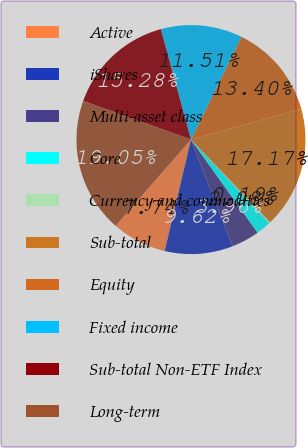Convert chart to OTSL. <chart><loc_0><loc_0><loc_500><loc_500><pie_chart><fcel>Active<fcel>iShares<fcel>Multi-asset class<fcel>Core<fcel>Currency and commodities<fcel>Sub-total<fcel>Equity<fcel>Fixed income<fcel>Sub-total Non-ETF Index<fcel>Long-term<nl><fcel>7.74%<fcel>9.62%<fcel>3.96%<fcel>2.08%<fcel>0.19%<fcel>17.17%<fcel>13.4%<fcel>11.51%<fcel>15.28%<fcel>19.05%<nl></chart> 